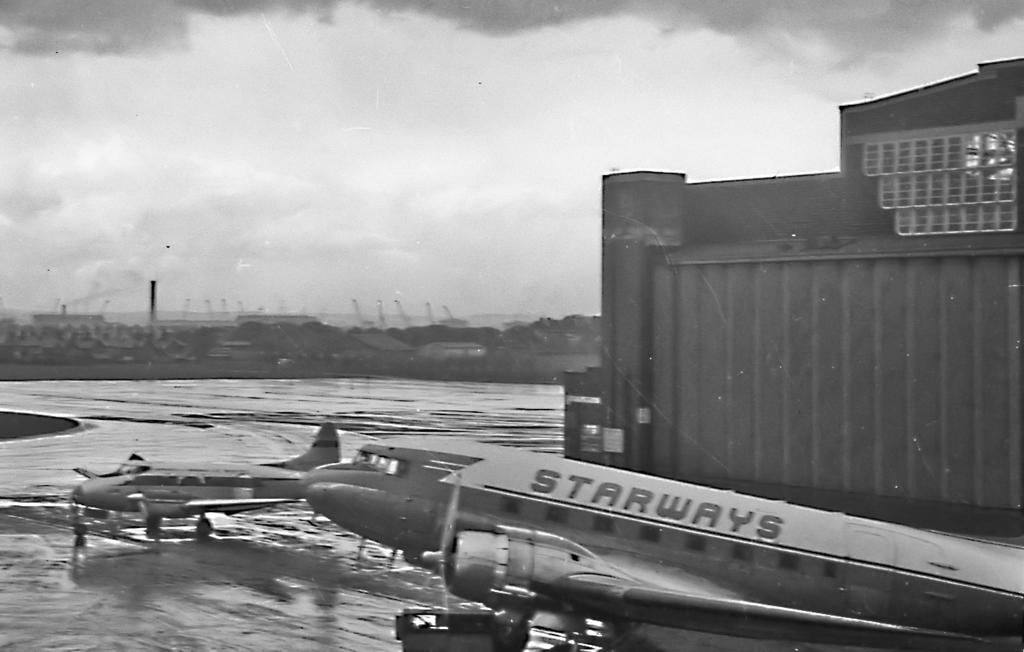What is the color scheme of the image? The image is black and white. What type of structures can be seen in the image? There are buildings in the image. What other objects are present in the image? There are poles and trees visible. What is the location of the aeroplanes in the image? The aeroplanes are on the road in the image. What is visible at the top of the image? The sky is visible at the top of the image. How many horses are pulling the buildings in the image? There are no horses present in the image, and the buildings are not being pulled by any animals. 